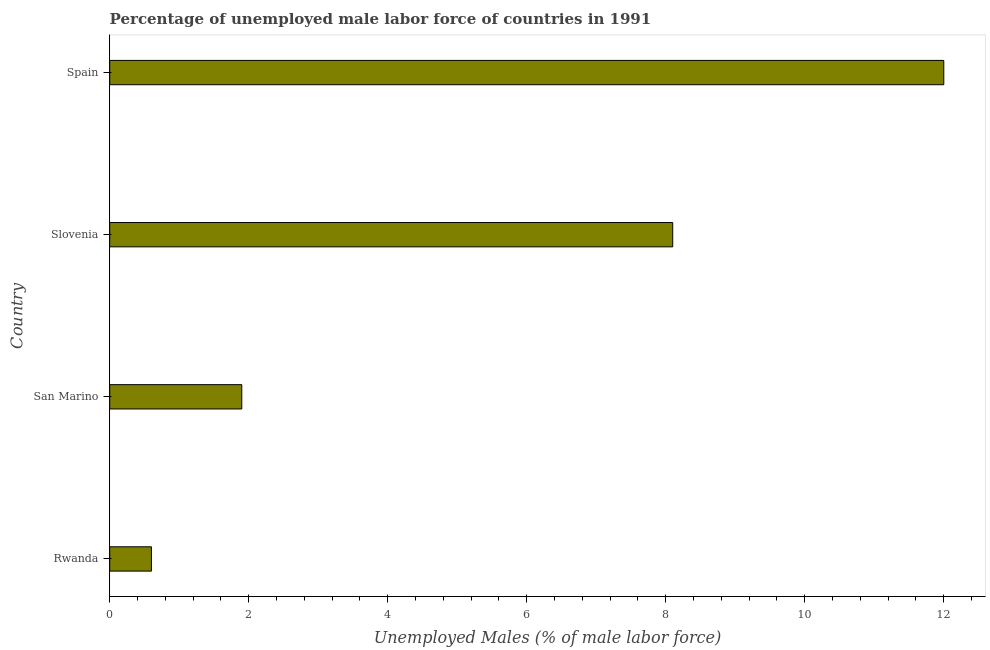What is the title of the graph?
Keep it short and to the point. Percentage of unemployed male labor force of countries in 1991. What is the label or title of the X-axis?
Offer a terse response. Unemployed Males (% of male labor force). What is the label or title of the Y-axis?
Offer a very short reply. Country. What is the total unemployed male labour force in Spain?
Provide a short and direct response. 12. Across all countries, what is the maximum total unemployed male labour force?
Your answer should be compact. 12. Across all countries, what is the minimum total unemployed male labour force?
Provide a succinct answer. 0.6. In which country was the total unemployed male labour force minimum?
Provide a short and direct response. Rwanda. What is the sum of the total unemployed male labour force?
Offer a very short reply. 22.6. What is the difference between the total unemployed male labour force in Rwanda and Slovenia?
Provide a succinct answer. -7.5. What is the average total unemployed male labour force per country?
Ensure brevity in your answer.  5.65. What is the median total unemployed male labour force?
Make the answer very short. 5. In how many countries, is the total unemployed male labour force greater than 7.2 %?
Give a very brief answer. 2. What is the ratio of the total unemployed male labour force in San Marino to that in Slovenia?
Keep it short and to the point. 0.23. How many bars are there?
Offer a very short reply. 4. Are the values on the major ticks of X-axis written in scientific E-notation?
Give a very brief answer. No. What is the Unemployed Males (% of male labor force) of Rwanda?
Provide a short and direct response. 0.6. What is the Unemployed Males (% of male labor force) in San Marino?
Offer a terse response. 1.9. What is the Unemployed Males (% of male labor force) of Slovenia?
Keep it short and to the point. 8.1. What is the difference between the Unemployed Males (% of male labor force) in Rwanda and San Marino?
Ensure brevity in your answer.  -1.3. What is the difference between the Unemployed Males (% of male labor force) in San Marino and Slovenia?
Your answer should be compact. -6.2. What is the difference between the Unemployed Males (% of male labor force) in San Marino and Spain?
Make the answer very short. -10.1. What is the difference between the Unemployed Males (% of male labor force) in Slovenia and Spain?
Ensure brevity in your answer.  -3.9. What is the ratio of the Unemployed Males (% of male labor force) in Rwanda to that in San Marino?
Your response must be concise. 0.32. What is the ratio of the Unemployed Males (% of male labor force) in Rwanda to that in Slovenia?
Your answer should be compact. 0.07. What is the ratio of the Unemployed Males (% of male labor force) in San Marino to that in Slovenia?
Make the answer very short. 0.23. What is the ratio of the Unemployed Males (% of male labor force) in San Marino to that in Spain?
Offer a very short reply. 0.16. What is the ratio of the Unemployed Males (% of male labor force) in Slovenia to that in Spain?
Make the answer very short. 0.68. 